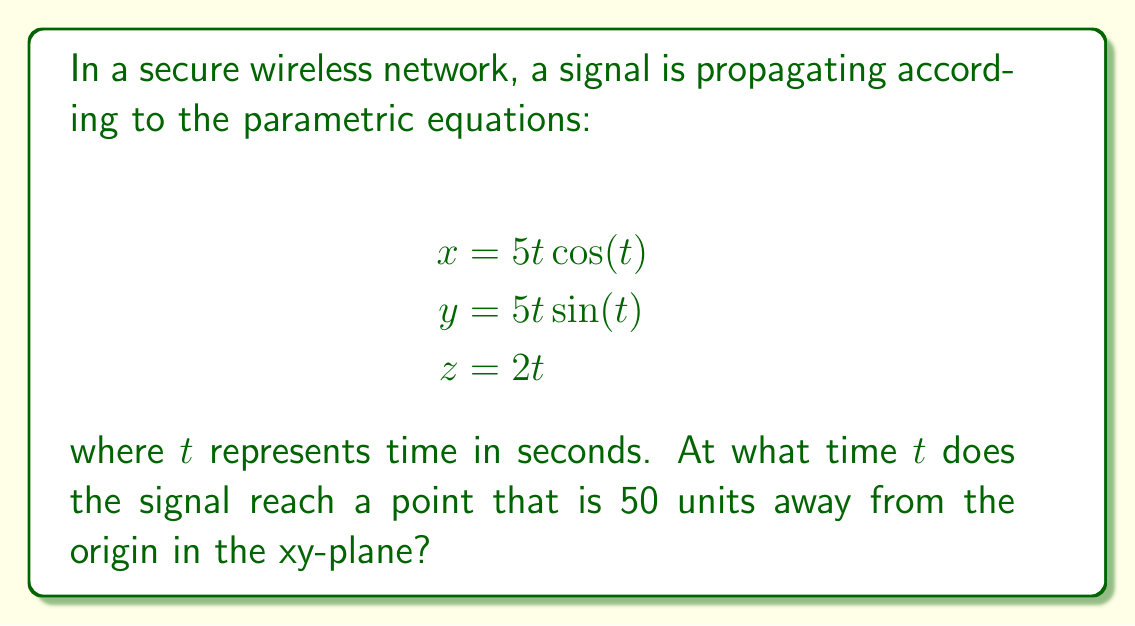Solve this math problem. To solve this problem, we need to follow these steps:

1) The distance from the origin in the xy-plane is given by $\sqrt{x^2 + y^2}$. We need to find when this equals 50.

2) Substitute the parametric equations:

   $$\sqrt{(5t\cos(t))^2 + (5t\sin(t))^2} = 50$$

3) Simplify using the identity $\cos^2(t) + \sin^2(t) = 1$:

   $$\sqrt{25t^2(\cos^2(t) + \sin^2(t))} = 50$$
   $$\sqrt{25t^2} = 50$$

4) Solve for $t$:

   $$5t = 50$$
   $$t = 10$$

5) Verify the solution by substituting $t=10$ into the original equations:

   $$x = 5(10)\cos(10) \approx -24.70$$
   $$y = 5(10)\sin(10) \approx 43.82$$
   $$z = 2(10) = 20$$

6) Check the distance in the xy-plane:

   $$\sqrt{(-24.70)^2 + (43.82)^2} \approx 50$$

This confirms our solution.
Answer: The signal reaches a point 50 units away from the origin in the xy-plane at $t = 10$ seconds. 